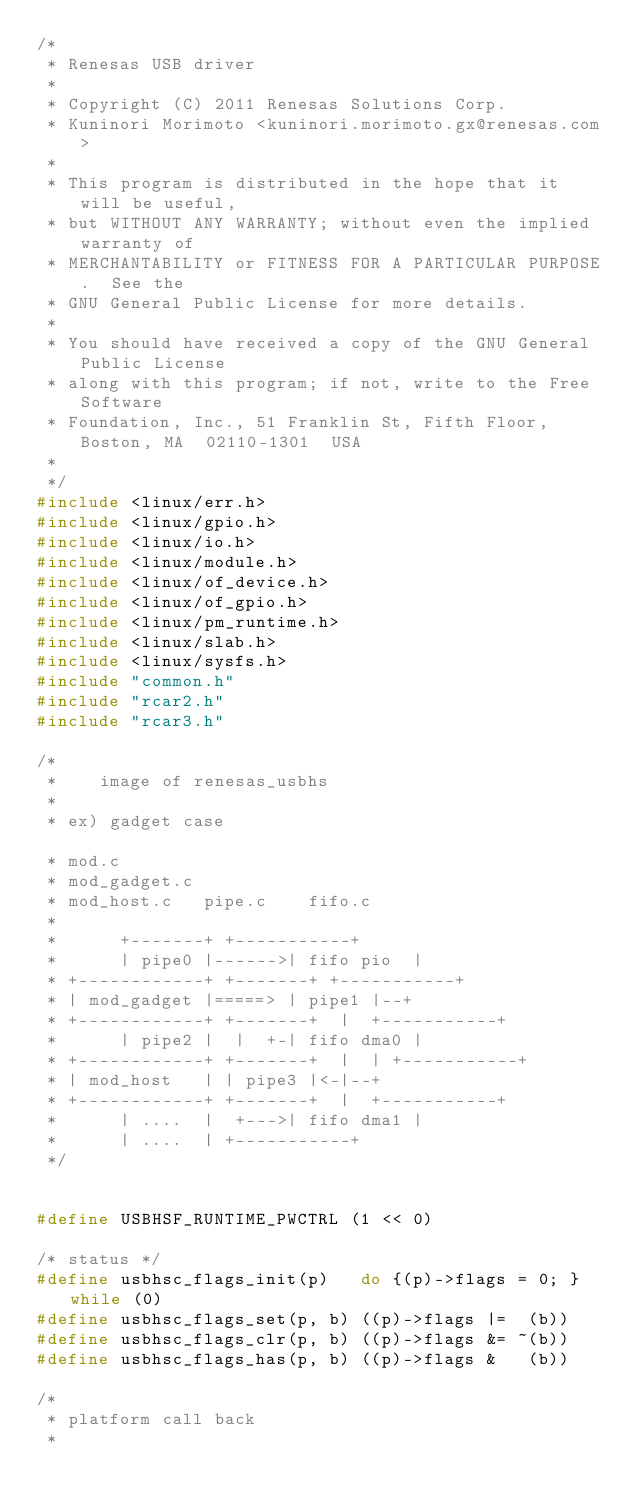Convert code to text. <code><loc_0><loc_0><loc_500><loc_500><_C_>/*
 * Renesas USB driver
 *
 * Copyright (C) 2011 Renesas Solutions Corp.
 * Kuninori Morimoto <kuninori.morimoto.gx@renesas.com>
 *
 * This program is distributed in the hope that it will be useful,
 * but WITHOUT ANY WARRANTY; without even the implied warranty of
 * MERCHANTABILITY or FITNESS FOR A PARTICULAR PURPOSE.  See the
 * GNU General Public License for more details.
 *
 * You should have received a copy of the GNU General Public License
 * along with this program; if not, write to the Free Software
 * Foundation, Inc., 51 Franklin St, Fifth Floor, Boston, MA  02110-1301  USA
 *
 */
#include <linux/err.h>
#include <linux/gpio.h>
#include <linux/io.h>
#include <linux/module.h>
#include <linux/of_device.h>
#include <linux/of_gpio.h>
#include <linux/pm_runtime.h>
#include <linux/slab.h>
#include <linux/sysfs.h>
#include "common.h"
#include "rcar2.h"
#include "rcar3.h"

/*
 *		image of renesas_usbhs
 *
 * ex) gadget case

 * mod.c
 * mod_gadget.c
 * mod_host.c		pipe.c		fifo.c
 *
 *			+-------+	+-----------+
 *			| pipe0 |------>| fifo pio  |
 * +------------+	+-------+	+-----------+
 * | mod_gadget |=====> | pipe1 |--+
 * +------------+	+-------+  |	+-----------+
 *			| pipe2 |  |  +-| fifo dma0 |
 * +------------+	+-------+  |  |	+-----------+
 * | mod_host   |	| pipe3 |<-|--+
 * +------------+	+-------+  |	+-----------+
 *			| ....  |  +--->| fifo dma1 |
 *			| ....  |	+-----------+
 */


#define USBHSF_RUNTIME_PWCTRL	(1 << 0)

/* status */
#define usbhsc_flags_init(p)   do {(p)->flags = 0; } while (0)
#define usbhsc_flags_set(p, b) ((p)->flags |=  (b))
#define usbhsc_flags_clr(p, b) ((p)->flags &= ~(b))
#define usbhsc_flags_has(p, b) ((p)->flags &   (b))

/*
 * platform call back
 *</code> 